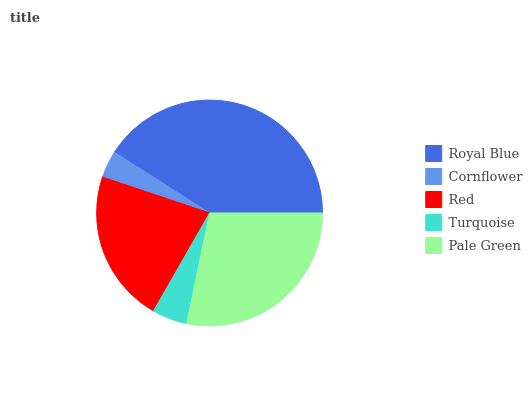Is Cornflower the minimum?
Answer yes or no. Yes. Is Royal Blue the maximum?
Answer yes or no. Yes. Is Red the minimum?
Answer yes or no. No. Is Red the maximum?
Answer yes or no. No. Is Red greater than Cornflower?
Answer yes or no. Yes. Is Cornflower less than Red?
Answer yes or no. Yes. Is Cornflower greater than Red?
Answer yes or no. No. Is Red less than Cornflower?
Answer yes or no. No. Is Red the high median?
Answer yes or no. Yes. Is Red the low median?
Answer yes or no. Yes. Is Royal Blue the high median?
Answer yes or no. No. Is Pale Green the low median?
Answer yes or no. No. 